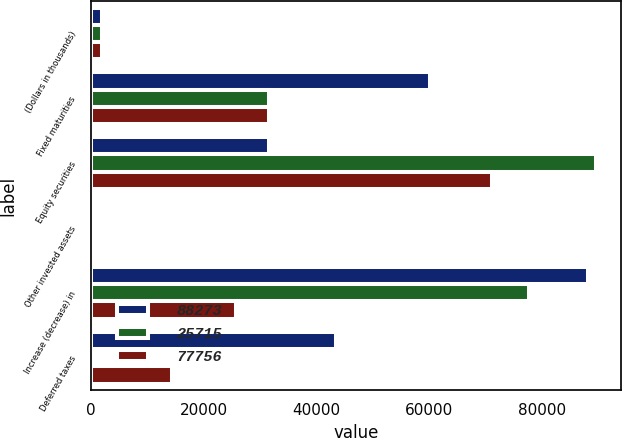Convert chart to OTSL. <chart><loc_0><loc_0><loc_500><loc_500><stacked_bar_chart><ecel><fcel>(Dollars in thousands)<fcel>Fixed maturities<fcel>Equity securities<fcel>Other invested assets<fcel>Increase (decrease) in<fcel>Deferred taxes<nl><fcel>88273<fcel>2006<fcel>60210<fcel>31608<fcel>466<fcel>88273<fcel>43399<nl><fcel>25715<fcel>2005<fcel>31608<fcel>89582<fcel>291<fcel>77756<fcel>31<nl><fcel>77756<fcel>2004<fcel>31608<fcel>71179<fcel>520<fcel>25715<fcel>14376<nl></chart> 